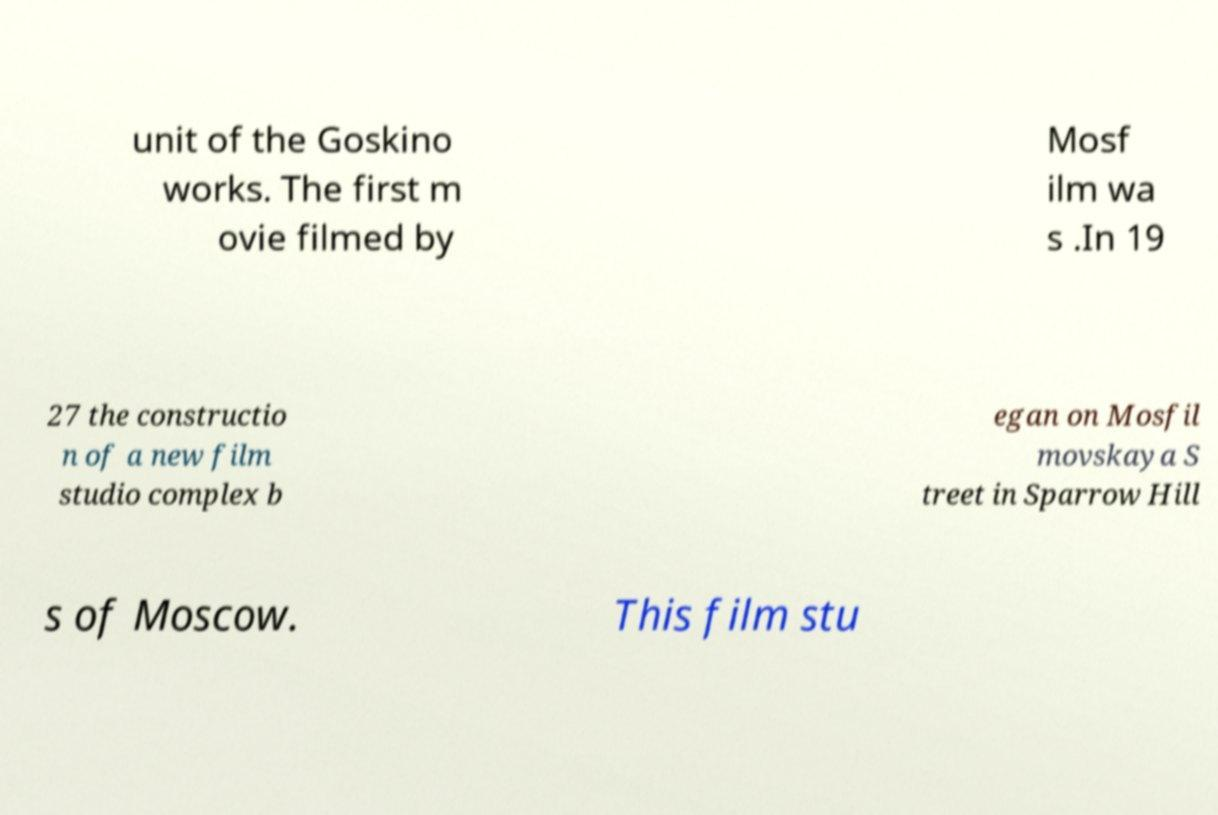Can you accurately transcribe the text from the provided image for me? unit of the Goskino works. The first m ovie filmed by Mosf ilm wa s .In 19 27 the constructio n of a new film studio complex b egan on Mosfil movskaya S treet in Sparrow Hill s of Moscow. This film stu 